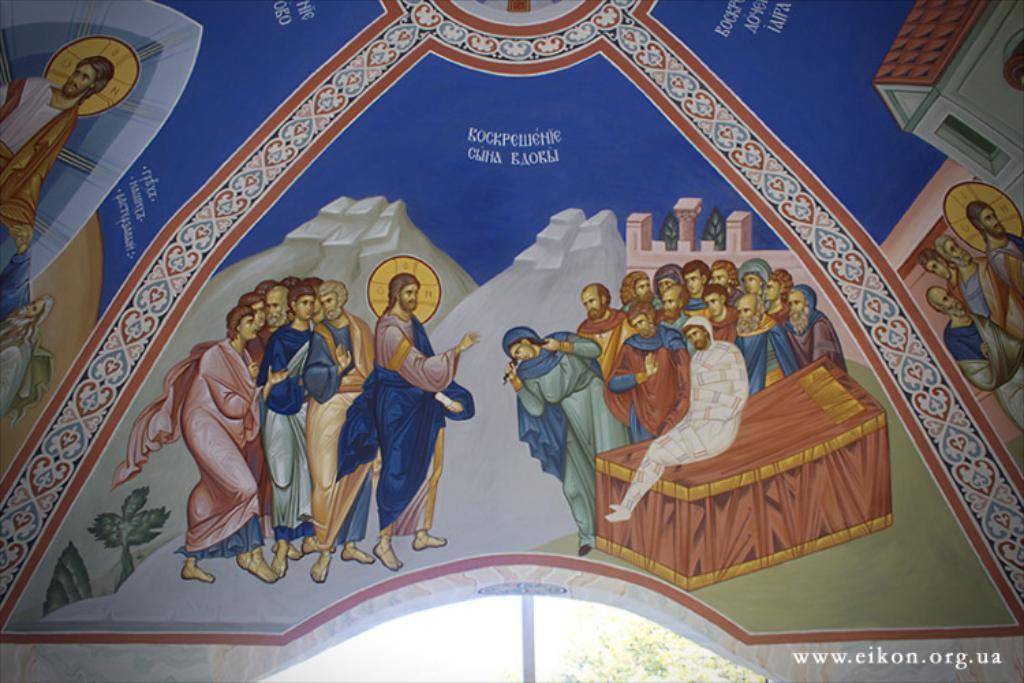Can you describe this image briefly? In this picture we can see some painting of people, house, plants and walls. We can see a person sitting on an object. There is a tree visible in the background. 